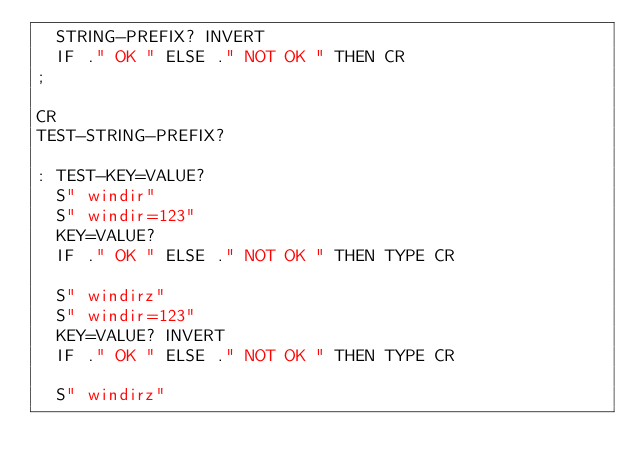Convert code to text. <code><loc_0><loc_0><loc_500><loc_500><_Forth_>  STRING-PREFIX? INVERT
  IF ." OK " ELSE ." NOT OK " THEN CR
;

CR
TEST-STRING-PREFIX?

: TEST-KEY=VALUE?
  S" windir"
  S" windir=123"
  KEY=VALUE?
  IF ." OK " ELSE ." NOT OK " THEN TYPE CR

  S" windirz"
  S" windir=123"
  KEY=VALUE? INVERT
  IF ." OK " ELSE ." NOT OK " THEN TYPE CR

  S" windirz"</code> 